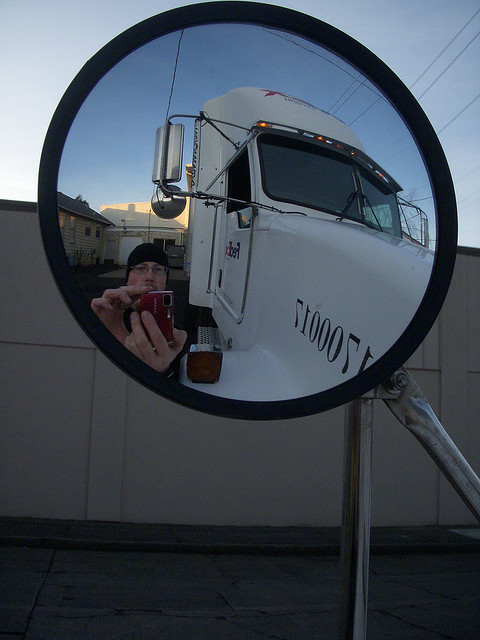<image>What is in the cup next to the driver? I am not sure what is in the cup next to the driver. It could be coffee, water or nothing at all. What does the writing on the right say? I am not sure. The writing on the right could be '710007', '1700017', or '510051'. What is the green thing being reflected on the mirror? I don't know what the green thing being reflected on the mirror is. It could be a light, a building, a truck, or a roof. What is in the cup next to the driver? I am not sure what is in the cup next to the driver. It can be seen 'coffee', 'water', 'liquid' or 'cards'. What does the writing on the right say? I don't know what the writing on the right says. It can be seen as '710007', '1700017', or '510051'. What is the green thing being reflected on the mirror? It is ambiguous what the green thing being reflected on the mirror is. It can be seen as a light, a building, or a truck. 